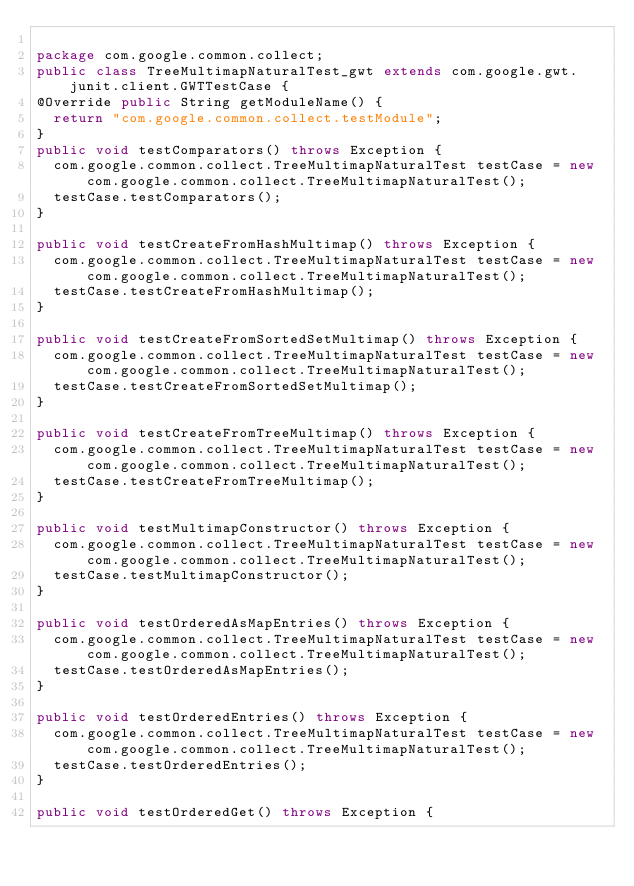Convert code to text. <code><loc_0><loc_0><loc_500><loc_500><_Java_>
package com.google.common.collect;
public class TreeMultimapNaturalTest_gwt extends com.google.gwt.junit.client.GWTTestCase {
@Override public String getModuleName() {
  return "com.google.common.collect.testModule";
}
public void testComparators() throws Exception {
  com.google.common.collect.TreeMultimapNaturalTest testCase = new com.google.common.collect.TreeMultimapNaturalTest();
  testCase.testComparators();
}

public void testCreateFromHashMultimap() throws Exception {
  com.google.common.collect.TreeMultimapNaturalTest testCase = new com.google.common.collect.TreeMultimapNaturalTest();
  testCase.testCreateFromHashMultimap();
}

public void testCreateFromSortedSetMultimap() throws Exception {
  com.google.common.collect.TreeMultimapNaturalTest testCase = new com.google.common.collect.TreeMultimapNaturalTest();
  testCase.testCreateFromSortedSetMultimap();
}

public void testCreateFromTreeMultimap() throws Exception {
  com.google.common.collect.TreeMultimapNaturalTest testCase = new com.google.common.collect.TreeMultimapNaturalTest();
  testCase.testCreateFromTreeMultimap();
}

public void testMultimapConstructor() throws Exception {
  com.google.common.collect.TreeMultimapNaturalTest testCase = new com.google.common.collect.TreeMultimapNaturalTest();
  testCase.testMultimapConstructor();
}

public void testOrderedAsMapEntries() throws Exception {
  com.google.common.collect.TreeMultimapNaturalTest testCase = new com.google.common.collect.TreeMultimapNaturalTest();
  testCase.testOrderedAsMapEntries();
}

public void testOrderedEntries() throws Exception {
  com.google.common.collect.TreeMultimapNaturalTest testCase = new com.google.common.collect.TreeMultimapNaturalTest();
  testCase.testOrderedEntries();
}

public void testOrderedGet() throws Exception {</code> 